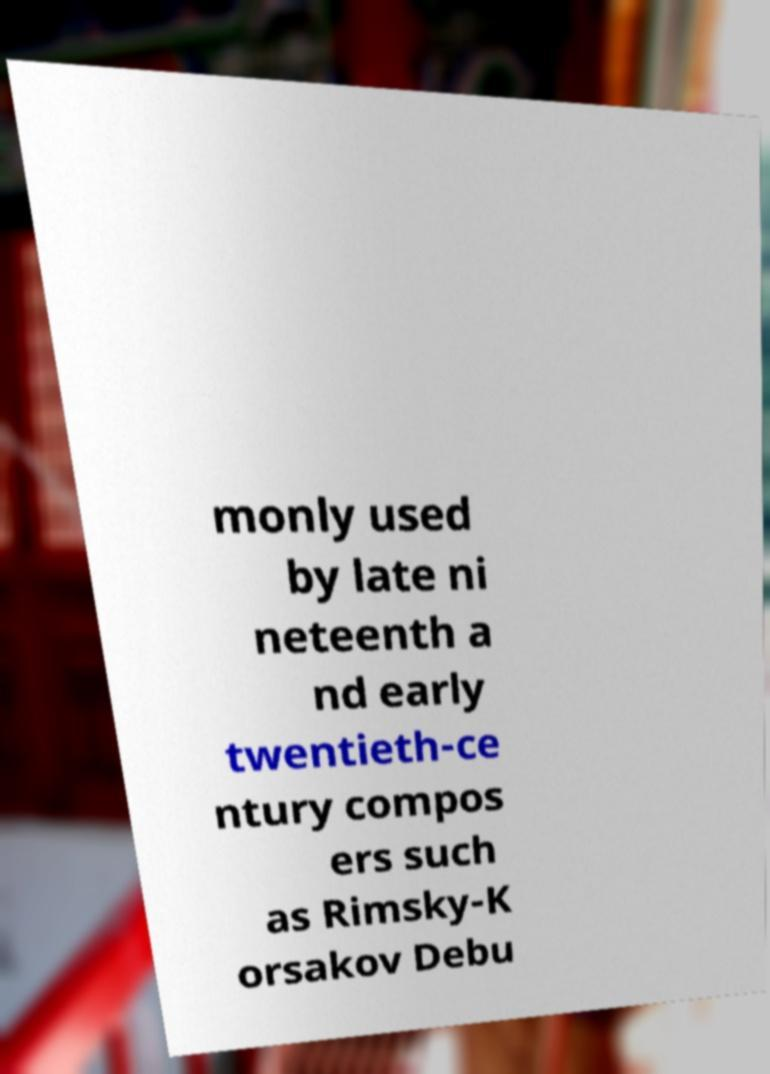For documentation purposes, I need the text within this image transcribed. Could you provide that? monly used by late ni neteenth a nd early twentieth-ce ntury compos ers such as Rimsky-K orsakov Debu 